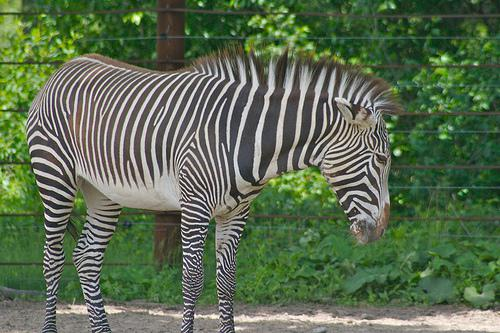Question: what is the zebra standing in front of?
Choices:
A. A watering hole.
B. A vast meadow.
C. Another zebra.
D. A fence.
Answer with the letter. Answer: D Question: what kind of animal is this?
Choices:
A. A hippo.
B. A vulture.
C. A rhino.
D. A zebra.
Answer with the letter. Answer: D Question: why is the zebra in front of a fence?
Choices:
A. It's in a zoo.
B. He wants in.
C. There is another zebra on the other side.
D. He sees food on the other side.
Answer with the letter. Answer: A 